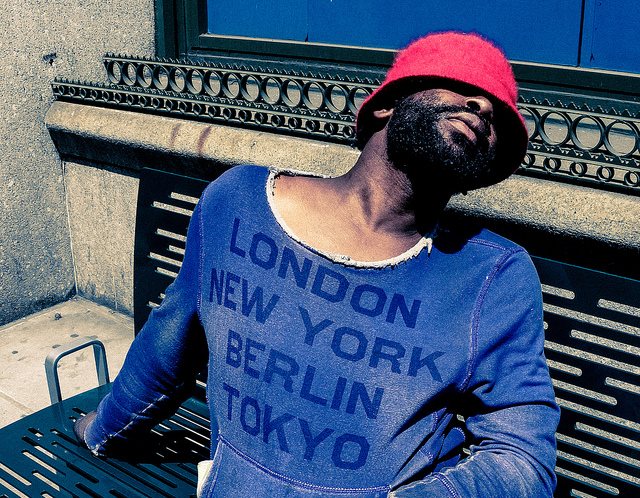Read all the text in this image. LONDON NEW YORK BERLIN TOKYO 